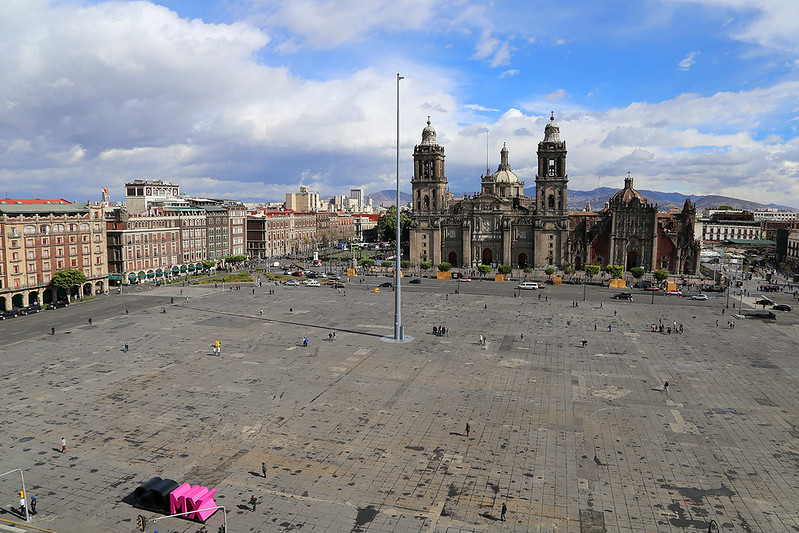Can you tell me more about the history of the Metropolitan Cathedral and its architectural style? Certainly! The Metropolitan Cathedral of Mexico City, prominently visible in the image, stands as the largest cathedral in the Americas. Its construction began in the 16th century and continued intermittently over the next 300 years, culminating in a blend of architectural styles, predominantly Baroque and Neo-Classical. The cathedral is renowned for its elaborately decorated altars, its twin bell towers, and a façade rich with religious statues and motifs. This building not only serves as a religious center but also showcases the historical layers of architectural trends and influences that have swept through Mexico over the centuries. 